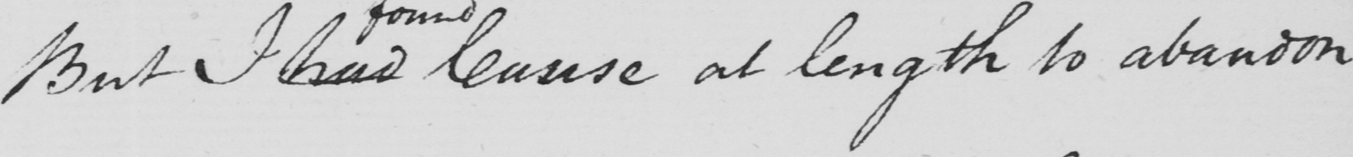Can you tell me what this handwritten text says? But I had Cause at length to abandon 